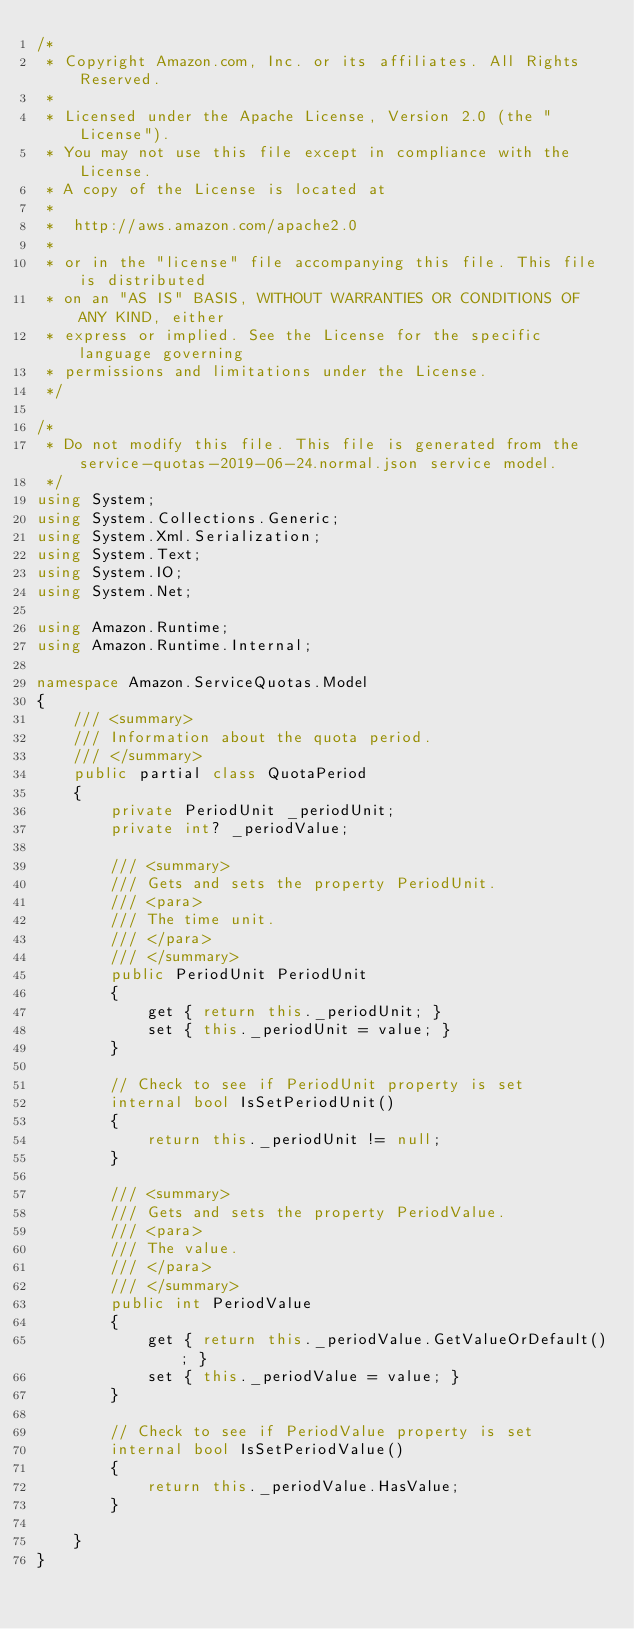<code> <loc_0><loc_0><loc_500><loc_500><_C#_>/*
 * Copyright Amazon.com, Inc. or its affiliates. All Rights Reserved.
 * 
 * Licensed under the Apache License, Version 2.0 (the "License").
 * You may not use this file except in compliance with the License.
 * A copy of the License is located at
 * 
 *  http://aws.amazon.com/apache2.0
 * 
 * or in the "license" file accompanying this file. This file is distributed
 * on an "AS IS" BASIS, WITHOUT WARRANTIES OR CONDITIONS OF ANY KIND, either
 * express or implied. See the License for the specific language governing
 * permissions and limitations under the License.
 */

/*
 * Do not modify this file. This file is generated from the service-quotas-2019-06-24.normal.json service model.
 */
using System;
using System.Collections.Generic;
using System.Xml.Serialization;
using System.Text;
using System.IO;
using System.Net;

using Amazon.Runtime;
using Amazon.Runtime.Internal;

namespace Amazon.ServiceQuotas.Model
{
    /// <summary>
    /// Information about the quota period.
    /// </summary>
    public partial class QuotaPeriod
    {
        private PeriodUnit _periodUnit;
        private int? _periodValue;

        /// <summary>
        /// Gets and sets the property PeriodUnit. 
        /// <para>
        /// The time unit.
        /// </para>
        /// </summary>
        public PeriodUnit PeriodUnit
        {
            get { return this._periodUnit; }
            set { this._periodUnit = value; }
        }

        // Check to see if PeriodUnit property is set
        internal bool IsSetPeriodUnit()
        {
            return this._periodUnit != null;
        }

        /// <summary>
        /// Gets and sets the property PeriodValue. 
        /// <para>
        /// The value.
        /// </para>
        /// </summary>
        public int PeriodValue
        {
            get { return this._periodValue.GetValueOrDefault(); }
            set { this._periodValue = value; }
        }

        // Check to see if PeriodValue property is set
        internal bool IsSetPeriodValue()
        {
            return this._periodValue.HasValue; 
        }

    }
}</code> 